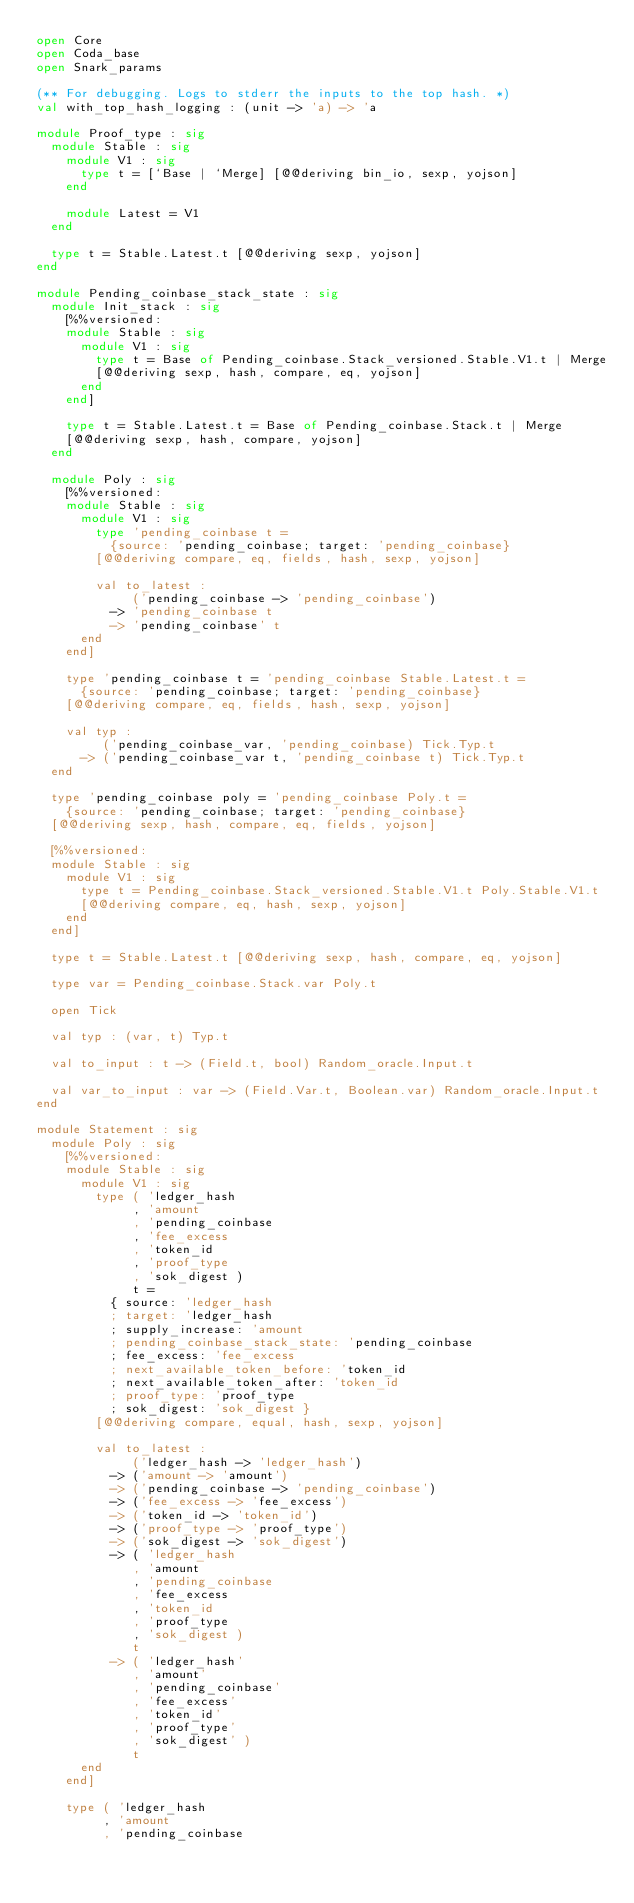Convert code to text. <code><loc_0><loc_0><loc_500><loc_500><_OCaml_>open Core
open Coda_base
open Snark_params

(** For debugging. Logs to stderr the inputs to the top hash. *)
val with_top_hash_logging : (unit -> 'a) -> 'a

module Proof_type : sig
  module Stable : sig
    module V1 : sig
      type t = [`Base | `Merge] [@@deriving bin_io, sexp, yojson]
    end

    module Latest = V1
  end

  type t = Stable.Latest.t [@@deriving sexp, yojson]
end

module Pending_coinbase_stack_state : sig
  module Init_stack : sig
    [%%versioned:
    module Stable : sig
      module V1 : sig
        type t = Base of Pending_coinbase.Stack_versioned.Stable.V1.t | Merge
        [@@deriving sexp, hash, compare, eq, yojson]
      end
    end]

    type t = Stable.Latest.t = Base of Pending_coinbase.Stack.t | Merge
    [@@deriving sexp, hash, compare, yojson]
  end

  module Poly : sig
    [%%versioned:
    module Stable : sig
      module V1 : sig
        type 'pending_coinbase t =
          {source: 'pending_coinbase; target: 'pending_coinbase}
        [@@deriving compare, eq, fields, hash, sexp, yojson]

        val to_latest :
             ('pending_coinbase -> 'pending_coinbase')
          -> 'pending_coinbase t
          -> 'pending_coinbase' t
      end
    end]

    type 'pending_coinbase t = 'pending_coinbase Stable.Latest.t =
      {source: 'pending_coinbase; target: 'pending_coinbase}
    [@@deriving compare, eq, fields, hash, sexp, yojson]

    val typ :
         ('pending_coinbase_var, 'pending_coinbase) Tick.Typ.t
      -> ('pending_coinbase_var t, 'pending_coinbase t) Tick.Typ.t
  end

  type 'pending_coinbase poly = 'pending_coinbase Poly.t =
    {source: 'pending_coinbase; target: 'pending_coinbase}
  [@@deriving sexp, hash, compare, eq, fields, yojson]

  [%%versioned:
  module Stable : sig
    module V1 : sig
      type t = Pending_coinbase.Stack_versioned.Stable.V1.t Poly.Stable.V1.t
      [@@deriving compare, eq, hash, sexp, yojson]
    end
  end]

  type t = Stable.Latest.t [@@deriving sexp, hash, compare, eq, yojson]

  type var = Pending_coinbase.Stack.var Poly.t

  open Tick

  val typ : (var, t) Typ.t

  val to_input : t -> (Field.t, bool) Random_oracle.Input.t

  val var_to_input : var -> (Field.Var.t, Boolean.var) Random_oracle.Input.t
end

module Statement : sig
  module Poly : sig
    [%%versioned:
    module Stable : sig
      module V1 : sig
        type ( 'ledger_hash
             , 'amount
             , 'pending_coinbase
             , 'fee_excess
             , 'token_id
             , 'proof_type
             , 'sok_digest )
             t =
          { source: 'ledger_hash
          ; target: 'ledger_hash
          ; supply_increase: 'amount
          ; pending_coinbase_stack_state: 'pending_coinbase
          ; fee_excess: 'fee_excess
          ; next_available_token_before: 'token_id
          ; next_available_token_after: 'token_id
          ; proof_type: 'proof_type
          ; sok_digest: 'sok_digest }
        [@@deriving compare, equal, hash, sexp, yojson]

        val to_latest :
             ('ledger_hash -> 'ledger_hash')
          -> ('amount -> 'amount')
          -> ('pending_coinbase -> 'pending_coinbase')
          -> ('fee_excess -> 'fee_excess')
          -> ('token_id -> 'token_id')
          -> ('proof_type -> 'proof_type')
          -> ('sok_digest -> 'sok_digest')
          -> ( 'ledger_hash
             , 'amount
             , 'pending_coinbase
             , 'fee_excess
             , 'token_id
             , 'proof_type
             , 'sok_digest )
             t
          -> ( 'ledger_hash'
             , 'amount'
             , 'pending_coinbase'
             , 'fee_excess'
             , 'token_id'
             , 'proof_type'
             , 'sok_digest' )
             t
      end
    end]

    type ( 'ledger_hash
         , 'amount
         , 'pending_coinbase</code> 